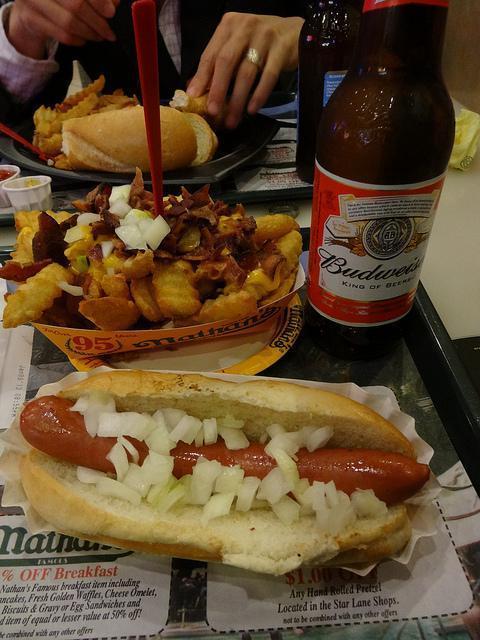How many rings are on the person's hand?
Give a very brief answer. 1. How many bottles are in the picture?
Give a very brief answer. 2. How many bikes are below the outdoor wall decorations?
Give a very brief answer. 0. 